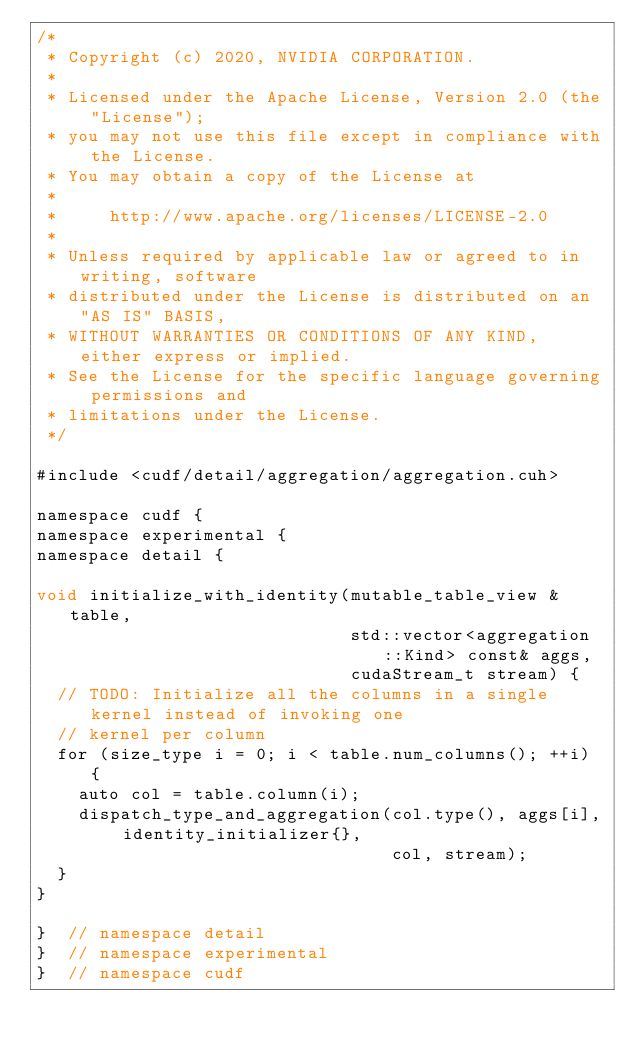<code> <loc_0><loc_0><loc_500><loc_500><_Cuda_>/*
 * Copyright (c) 2020, NVIDIA CORPORATION.
 *
 * Licensed under the Apache License, Version 2.0 (the "License");
 * you may not use this file except in compliance with the License.
 * You may obtain a copy of the License at
 *
 *     http://www.apache.org/licenses/LICENSE-2.0
 *
 * Unless required by applicable law or agreed to in writing, software
 * distributed under the License is distributed on an "AS IS" BASIS,
 * WITHOUT WARRANTIES OR CONDITIONS OF ANY KIND, either express or implied.
 * See the License for the specific language governing permissions and
 * limitations under the License.
 */

#include <cudf/detail/aggregation/aggregation.cuh>

namespace cudf {
namespace experimental {
namespace detail {

void initialize_with_identity(mutable_table_view & table,
                              std::vector<aggregation::Kind> const& aggs,
                              cudaStream_t stream) {
  // TODO: Initialize all the columns in a single kernel instead of invoking one
  // kernel per column
  for (size_type i = 0; i < table.num_columns(); ++i) {
    auto col = table.column(i);
    dispatch_type_and_aggregation(col.type(), aggs[i], identity_initializer{}, 
                                  col, stream);
  }
}

}  // namespace detail
}  // namespace experimental
}  // namespace cudf
</code> 